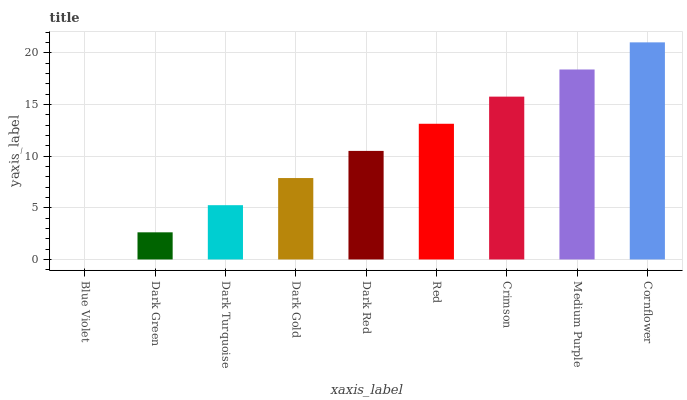Is Dark Green the minimum?
Answer yes or no. No. Is Dark Green the maximum?
Answer yes or no. No. Is Dark Green greater than Blue Violet?
Answer yes or no. Yes. Is Blue Violet less than Dark Green?
Answer yes or no. Yes. Is Blue Violet greater than Dark Green?
Answer yes or no. No. Is Dark Green less than Blue Violet?
Answer yes or no. No. Is Dark Red the high median?
Answer yes or no. Yes. Is Dark Red the low median?
Answer yes or no. Yes. Is Dark Green the high median?
Answer yes or no. No. Is Crimson the low median?
Answer yes or no. No. 